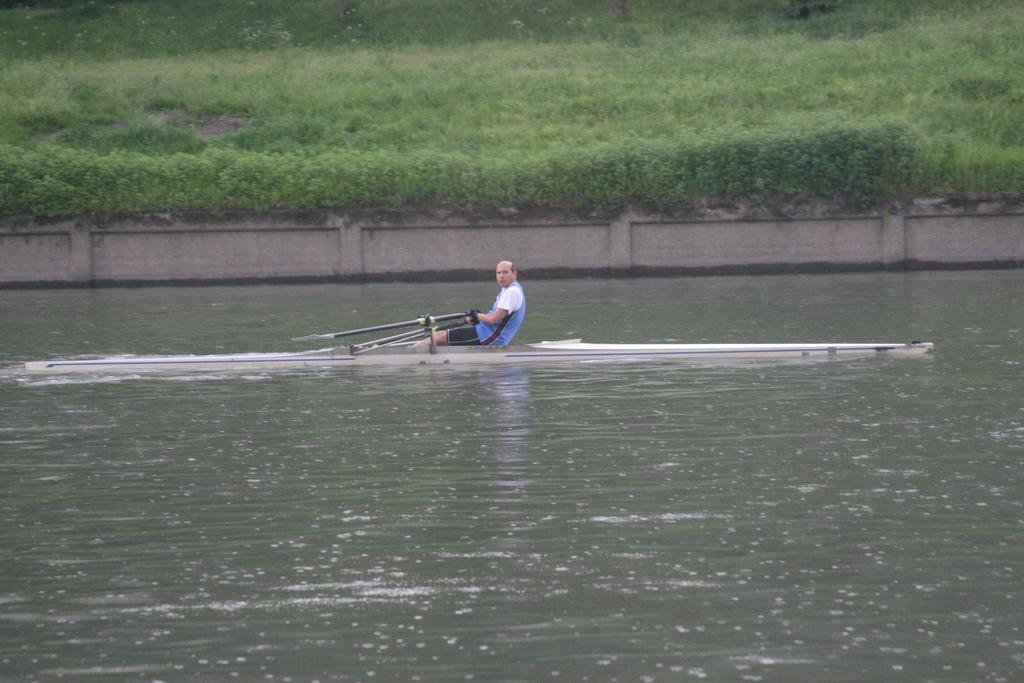What is the main subject of the image? There is a person sailing on a boat in the water. What is the person sailing on? The person is sailing on a boat in the water. What can be seen in the background of the image? There is a wall, plants, and grass in the background of the image. How many quinces are floating in the water next to the boat? There are no quinces present in the image; it features a person sailing on a boat in the water. Can you see any fish swimming near the boat? There is no mention of fish in the image; it only shows a person sailing on a boat in the water. 